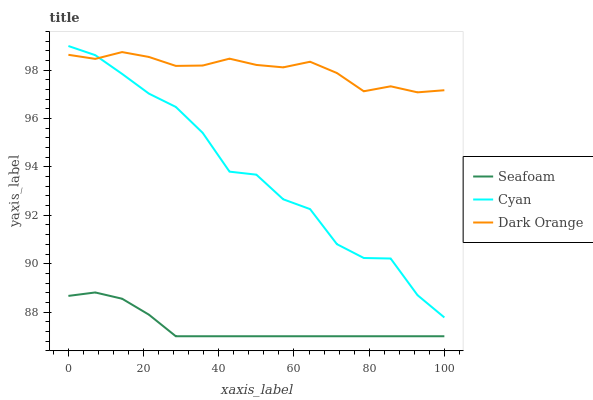Does Seafoam have the minimum area under the curve?
Answer yes or no. Yes. Does Dark Orange have the maximum area under the curve?
Answer yes or no. Yes. Does Dark Orange have the minimum area under the curve?
Answer yes or no. No. Does Seafoam have the maximum area under the curve?
Answer yes or no. No. Is Seafoam the smoothest?
Answer yes or no. Yes. Is Cyan the roughest?
Answer yes or no. Yes. Is Dark Orange the smoothest?
Answer yes or no. No. Is Dark Orange the roughest?
Answer yes or no. No. Does Seafoam have the lowest value?
Answer yes or no. Yes. Does Dark Orange have the lowest value?
Answer yes or no. No. Does Cyan have the highest value?
Answer yes or no. Yes. Does Dark Orange have the highest value?
Answer yes or no. No. Is Seafoam less than Cyan?
Answer yes or no. Yes. Is Cyan greater than Seafoam?
Answer yes or no. Yes. Does Cyan intersect Dark Orange?
Answer yes or no. Yes. Is Cyan less than Dark Orange?
Answer yes or no. No. Is Cyan greater than Dark Orange?
Answer yes or no. No. Does Seafoam intersect Cyan?
Answer yes or no. No. 